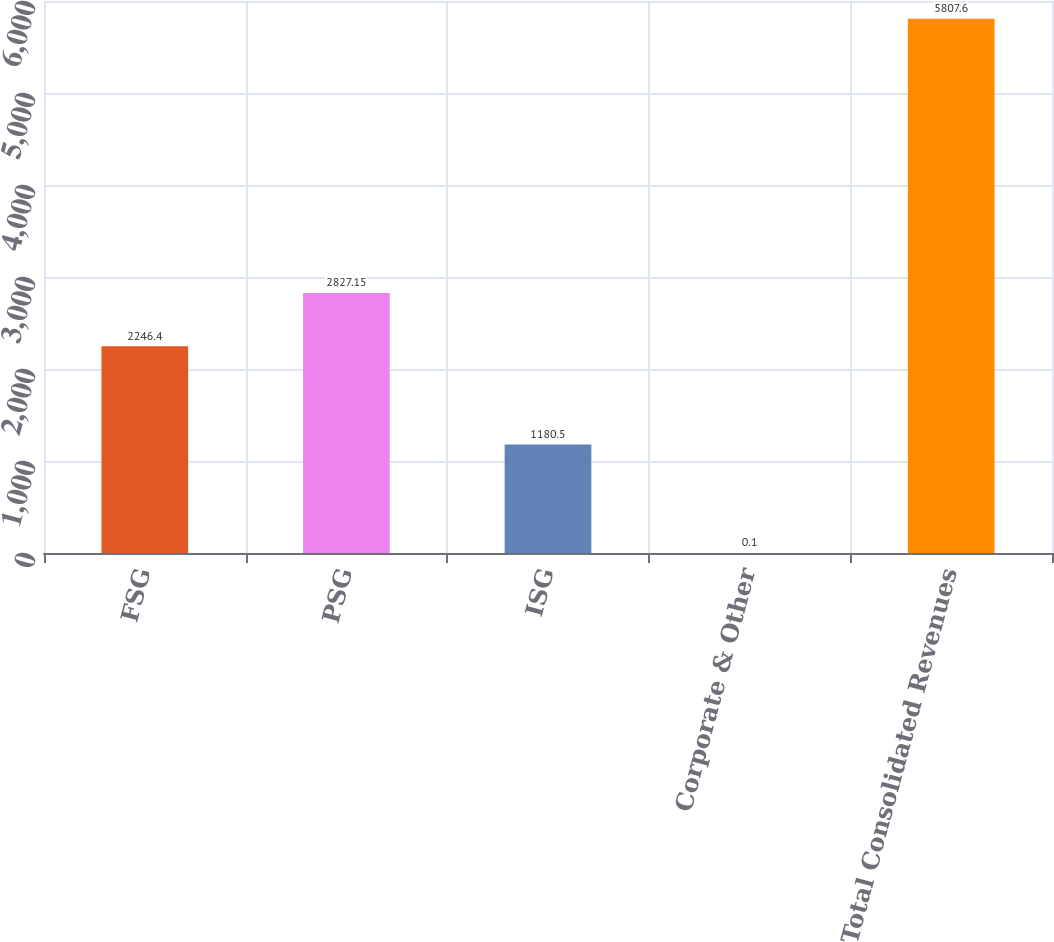<chart> <loc_0><loc_0><loc_500><loc_500><bar_chart><fcel>FSG<fcel>PSG<fcel>ISG<fcel>Corporate & Other<fcel>Total Consolidated Revenues<nl><fcel>2246.4<fcel>2827.15<fcel>1180.5<fcel>0.1<fcel>5807.6<nl></chart> 